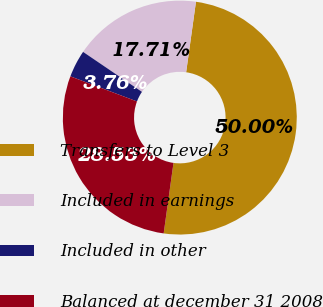Convert chart. <chart><loc_0><loc_0><loc_500><loc_500><pie_chart><fcel>Transfers to Level 3<fcel>Included in earnings<fcel>Included in other<fcel>Balanced at december 31 2008<nl><fcel>50.0%<fcel>17.71%<fcel>3.76%<fcel>28.53%<nl></chart> 